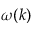<formula> <loc_0><loc_0><loc_500><loc_500>\omega ( k )</formula> 